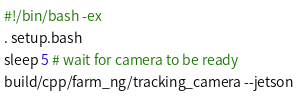<code> <loc_0><loc_0><loc_500><loc_500><_Bash_>#!/bin/bash -ex
. setup.bash
sleep 5 # wait for camera to be ready
build/cpp/farm_ng/tracking_camera --jetson
</code> 